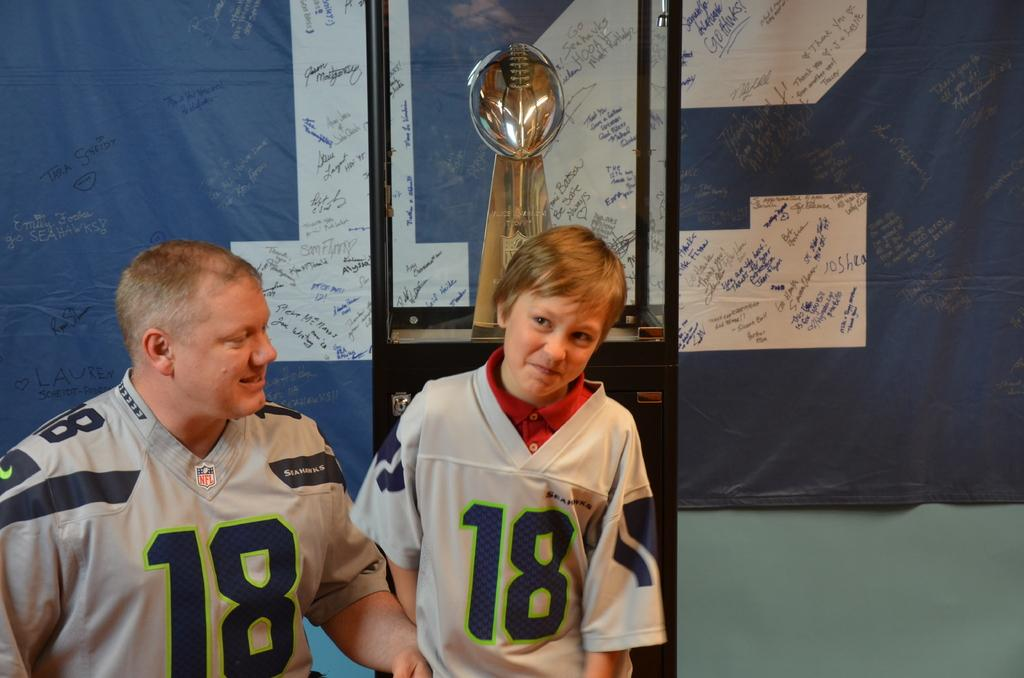Provide a one-sentence caption for the provided image. a man and boy in number 18 jerseys standing in front of a football trophy. 